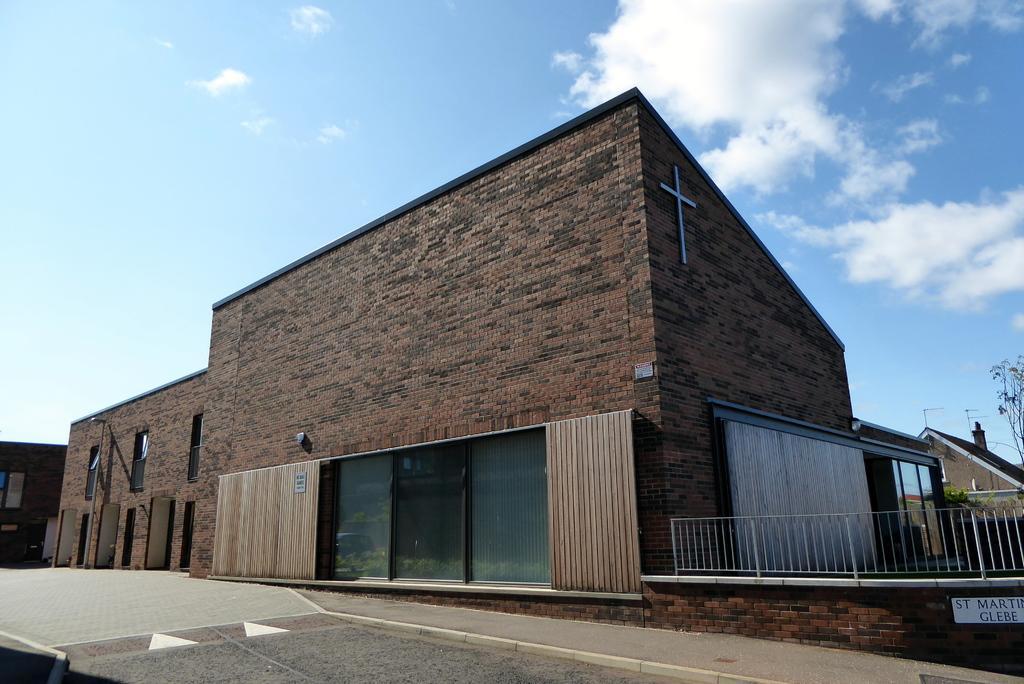How would you summarize this image in a sentence or two? In this picture we can see road, buildings, boards, railing, light pole, windows and trees. We can see cross symbol on the wall. In the background of the image we can see the sky with clouds. 